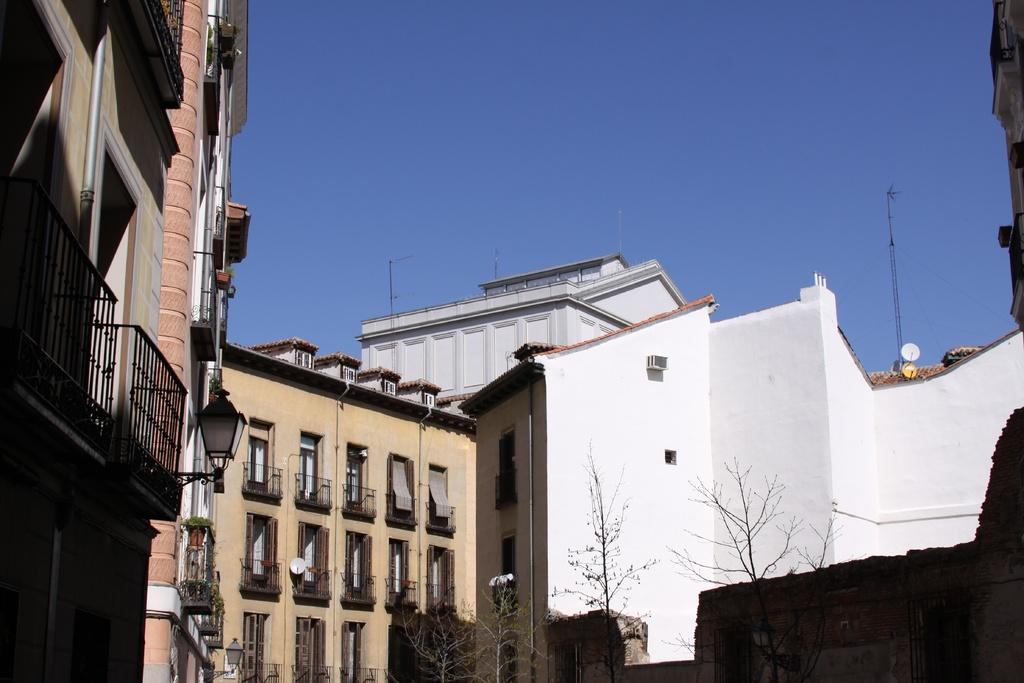What type of vegetation is at the bottom of the image? There are trees at the bottom of the image. What type of structures are in the middle of the image? There are big buildings in the middle of the image. What color is the sky at the top of the image? The sky is blue at the top of the image. Where is the hose located in the image? There is no hose present in the image. What type of wire is connecting the buildings in the image? There is no wire connecting the buildings in the image. 